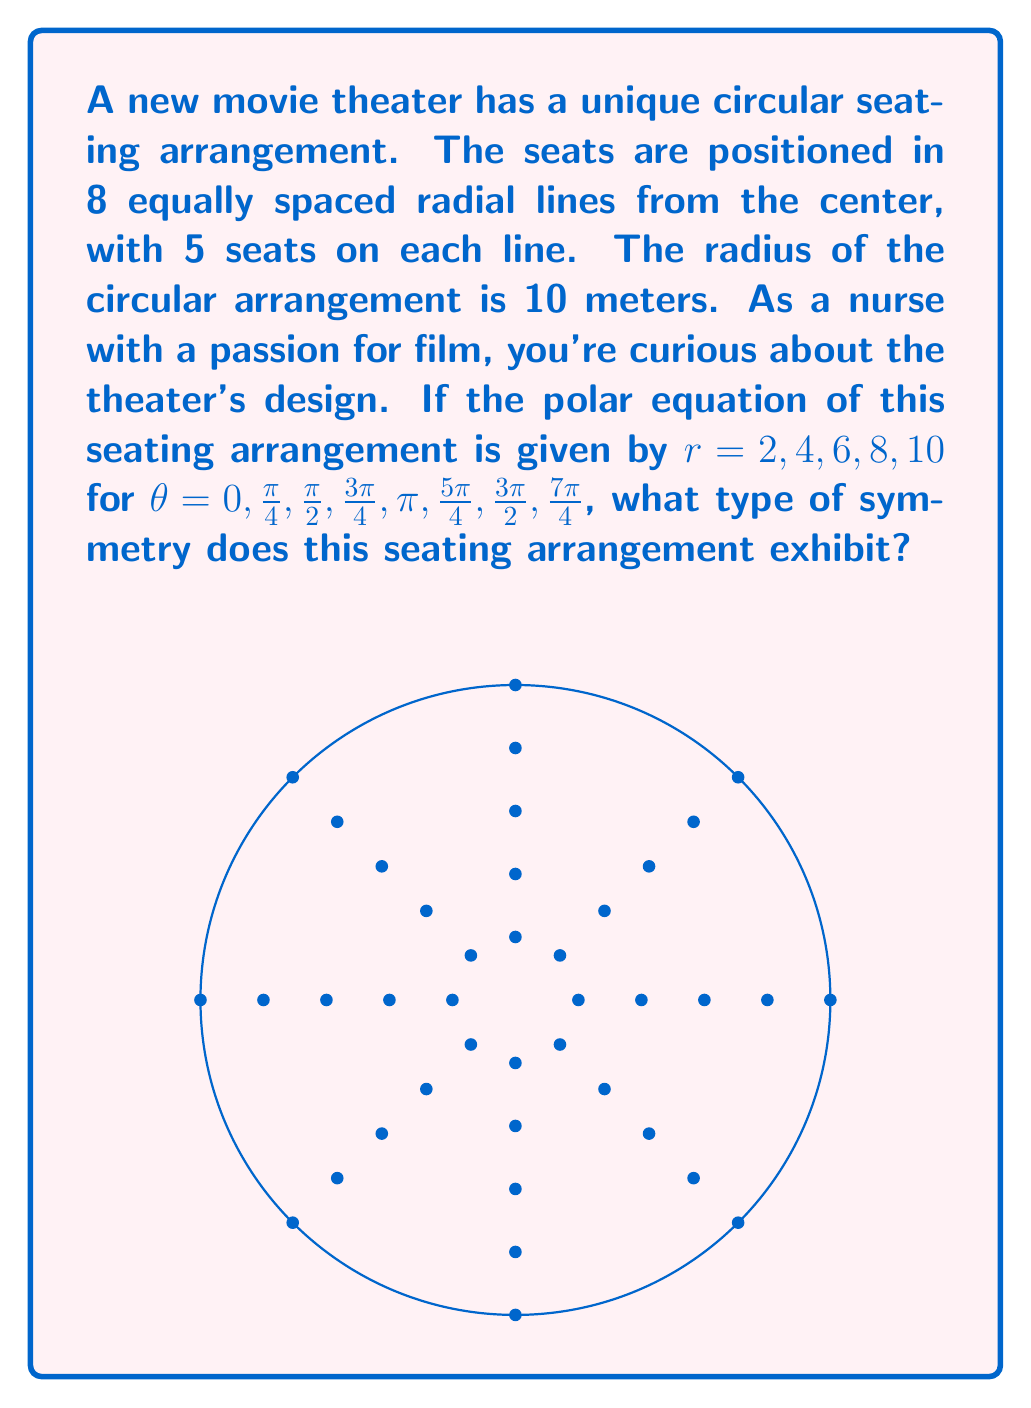Help me with this question. To determine the symmetry of the seating arrangement, we need to analyze the polar equation and the resulting graph:

1) The radial component $r$ takes values 2, 4, 6, 8, and 10, which represent the distances of seats from the center.

2) The angular component $\theta$ is given in multiples of $\frac{\pi}{4}$, creating 8 equally spaced radial lines.

3) Let's check for different types of symmetry:

   a) Reflection symmetry about the x-axis: 
      If $(r,\theta)$ is a point, then $(r,-\theta)$ should also be a point.
      This is true for all points in our arrangement.

   b) Reflection symmetry about the y-axis:
      If $(r,\theta)$ is a point, then $(r,\pi-\theta)$ should also be a point.
      This is also true for all points.

   c) Origin symmetry:
      If $(r,\theta)$ is a point, then $(r,\theta+\pi)$ should also be a point.
      This is true for all points in our arrangement.

4) The arrangement also exhibits rotational symmetry of order 8, as rotating by $\frac{\pi}{4}$ (or any multiple of it) produces the same pattern.

Therefore, this seating arrangement exhibits both reflectional symmetry (about x and y axes) and rotational symmetry.
Answer: The seating arrangement exhibits reflectional and 8-fold rotational symmetry. 